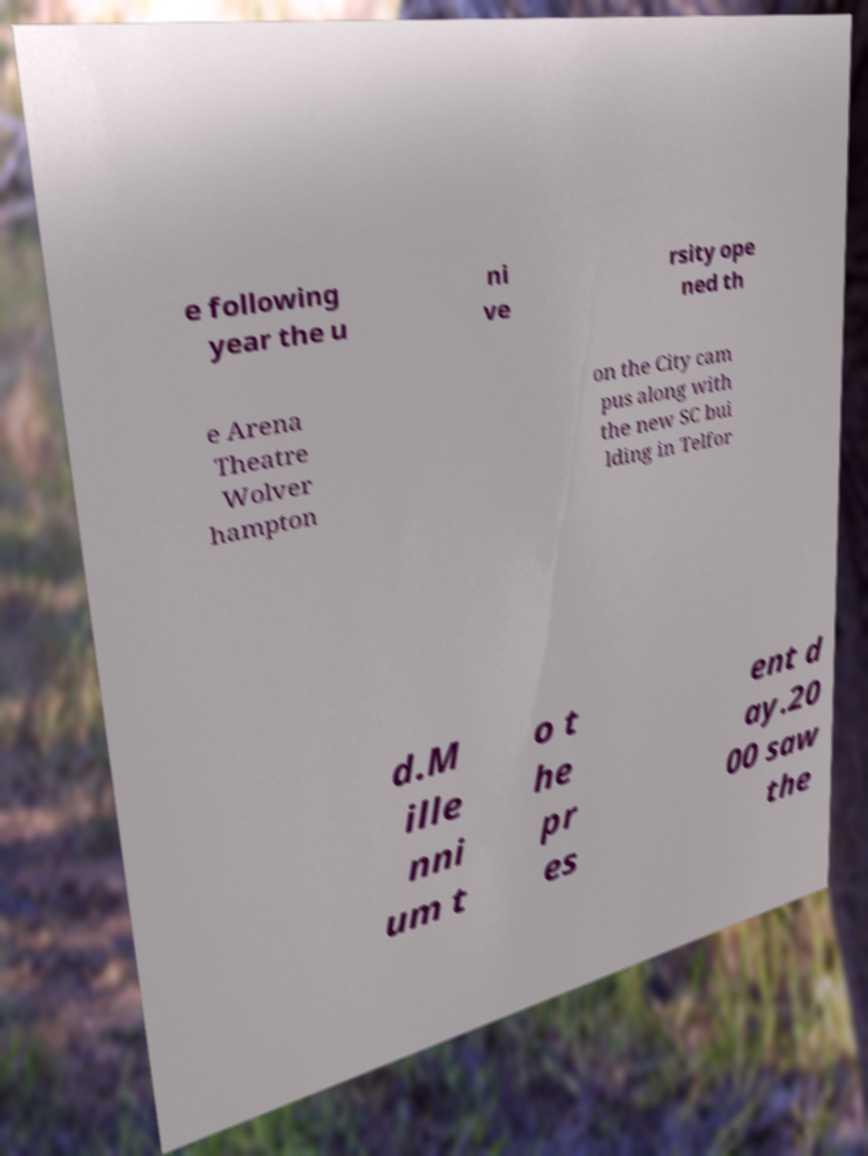For documentation purposes, I need the text within this image transcribed. Could you provide that? e following year the u ni ve rsity ope ned th e Arena Theatre Wolver hampton on the City cam pus along with the new SC bui lding in Telfor d.M ille nni um t o t he pr es ent d ay.20 00 saw the 